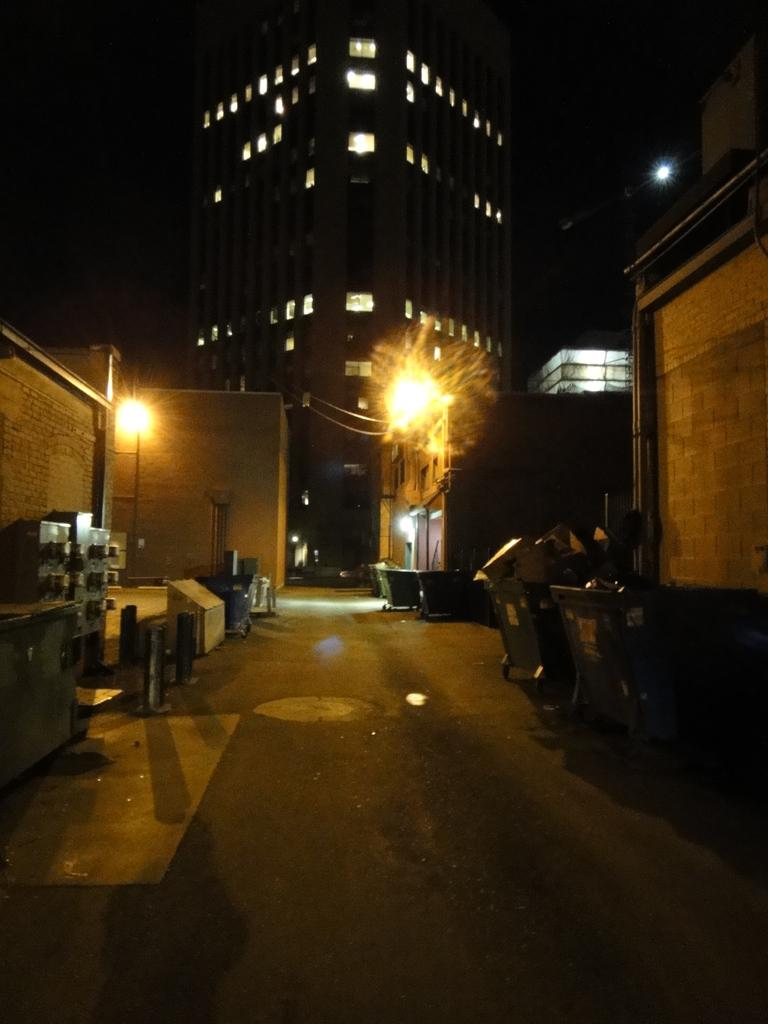What type of structures can be seen in the image? There are buildings in the image. What is located in the middle of the image? There are lights in the middle of the image. What objects are present on the road in the image? There are trash bins on the road. Where is the panel board located in the image? The panel board is on the left side of the image. What type of agreement is being discussed in the image? There is no indication of an agreement being discussed in the image. Can you see any cream in the image? There is no cream present in the image. 